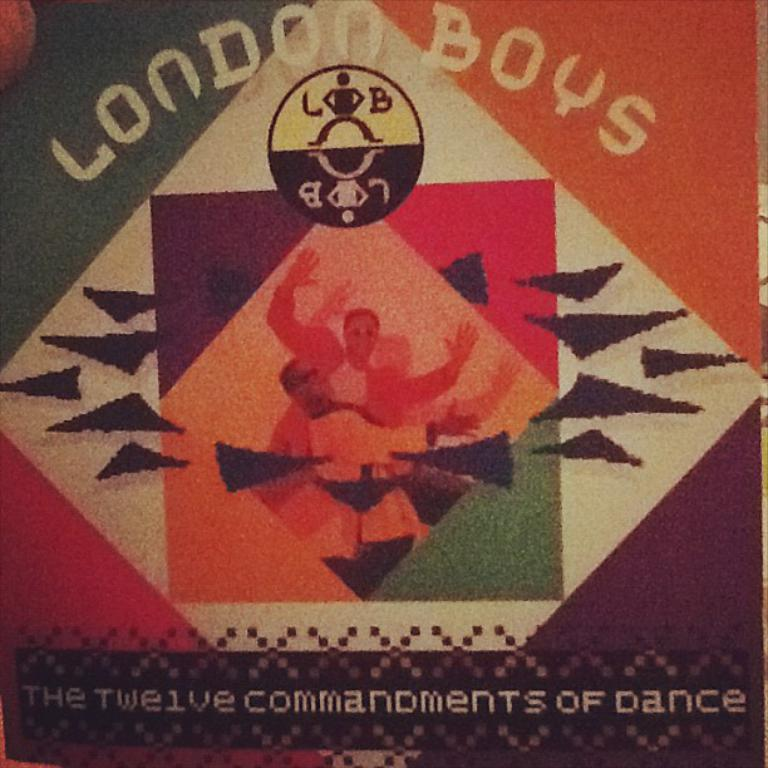Provide a one-sentence caption for the provided image. An album cover of the twelve commandments of dance by the London Boys. 